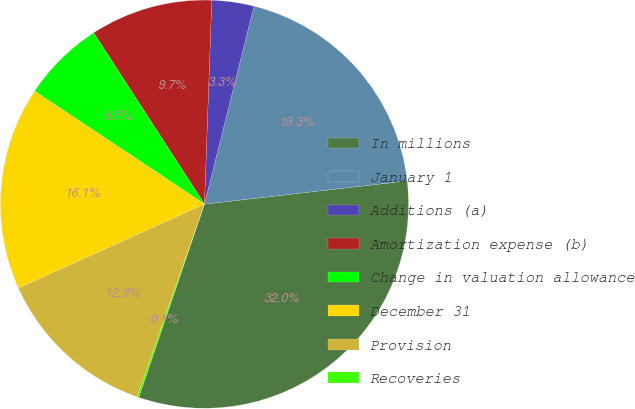Convert chart. <chart><loc_0><loc_0><loc_500><loc_500><pie_chart><fcel>In millions<fcel>January 1<fcel>Additions (a)<fcel>Amortization expense (b)<fcel>Change in valuation allowance<fcel>December 31<fcel>Provision<fcel>Recoveries<nl><fcel>32.03%<fcel>19.28%<fcel>3.33%<fcel>9.71%<fcel>6.52%<fcel>16.09%<fcel>12.9%<fcel>0.14%<nl></chart> 